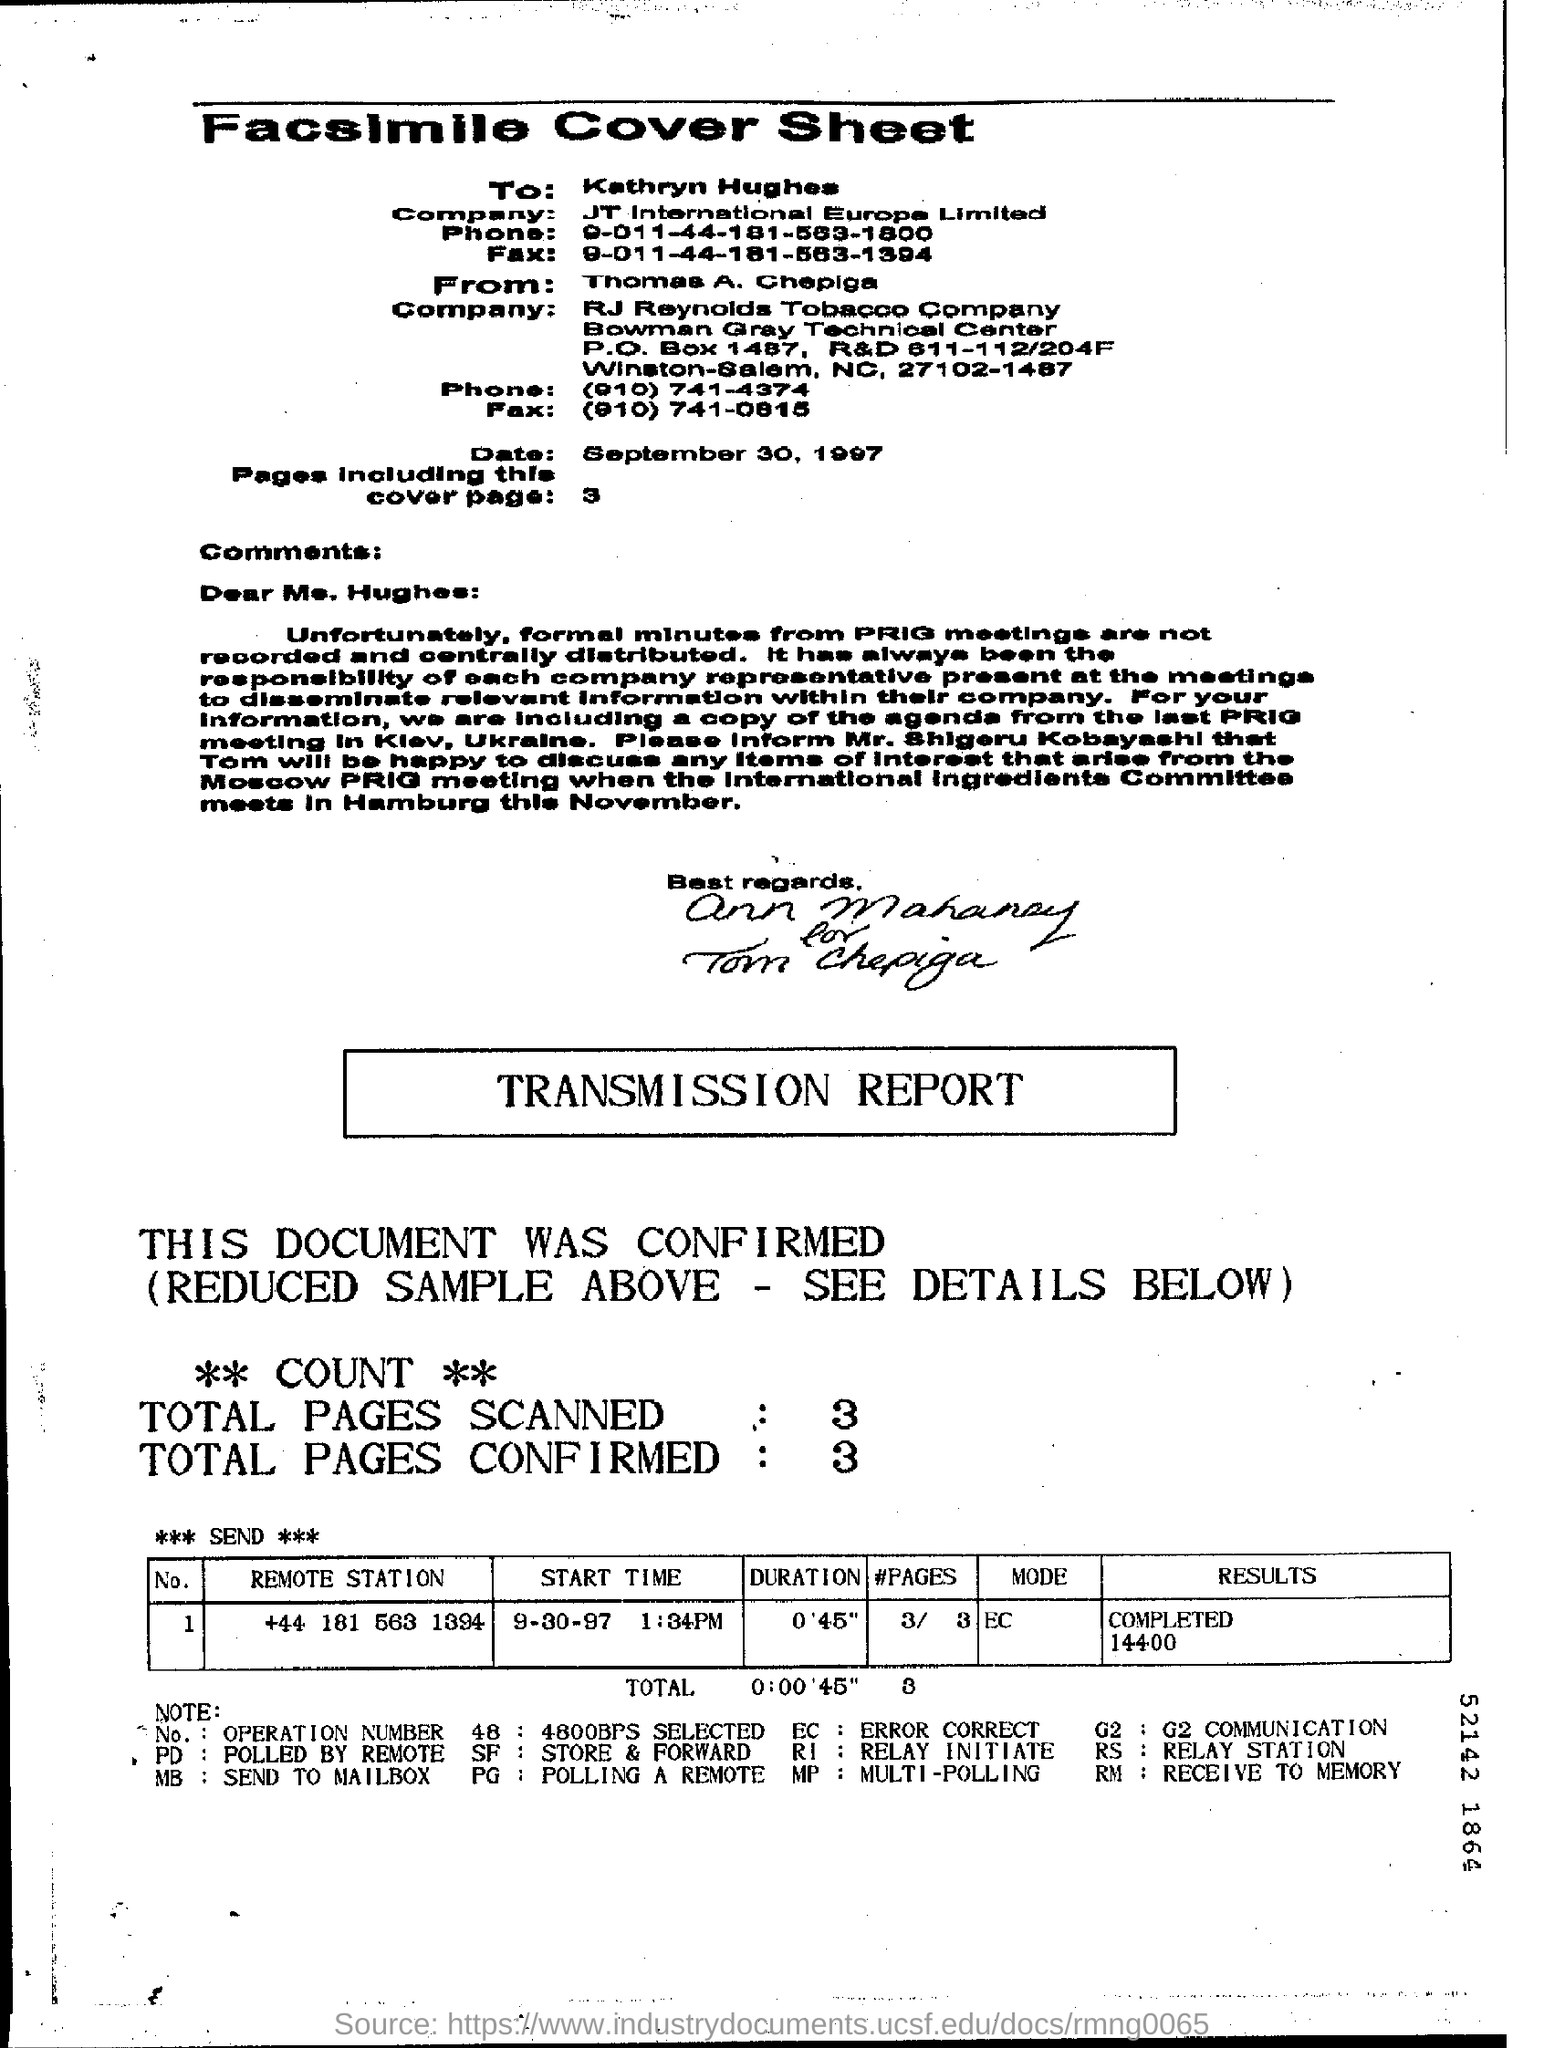Indicate a few pertinent items in this graphic. The heading of this page is 'Facsimile Cover Sheet.' 